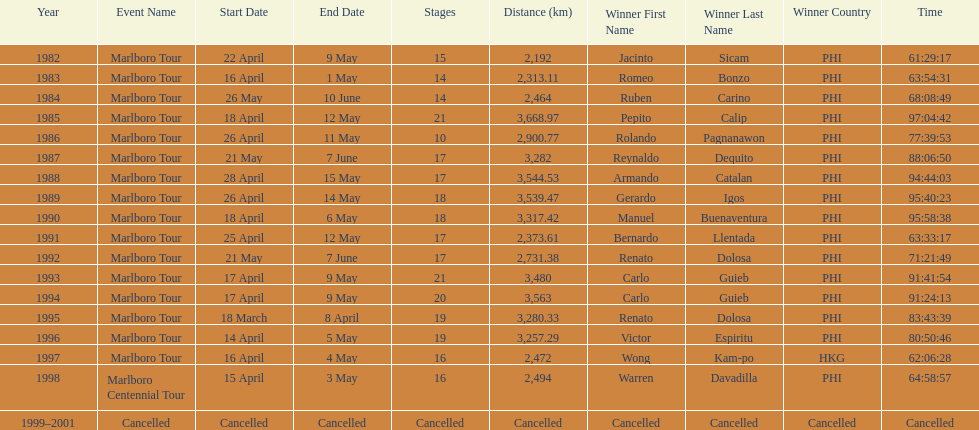How long did it take warren davadilla to complete the 1998 marlboro centennial tour? 64:58:57. 